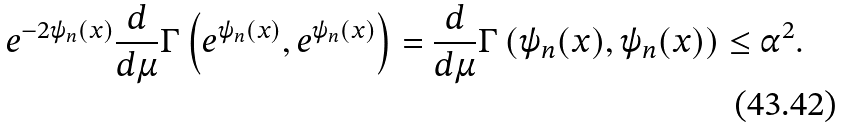<formula> <loc_0><loc_0><loc_500><loc_500>e ^ { - 2 \psi _ { n } ( x ) } \frac { d } { d \mu } \Gamma \left ( e ^ { \psi _ { n } ( x ) } , e ^ { \psi _ { n } ( x ) } \right ) = \frac { d } { d \mu } \Gamma \left ( \psi _ { n } ( x ) , \psi _ { n } ( x ) \right ) \leq \alpha ^ { 2 } .</formula> 